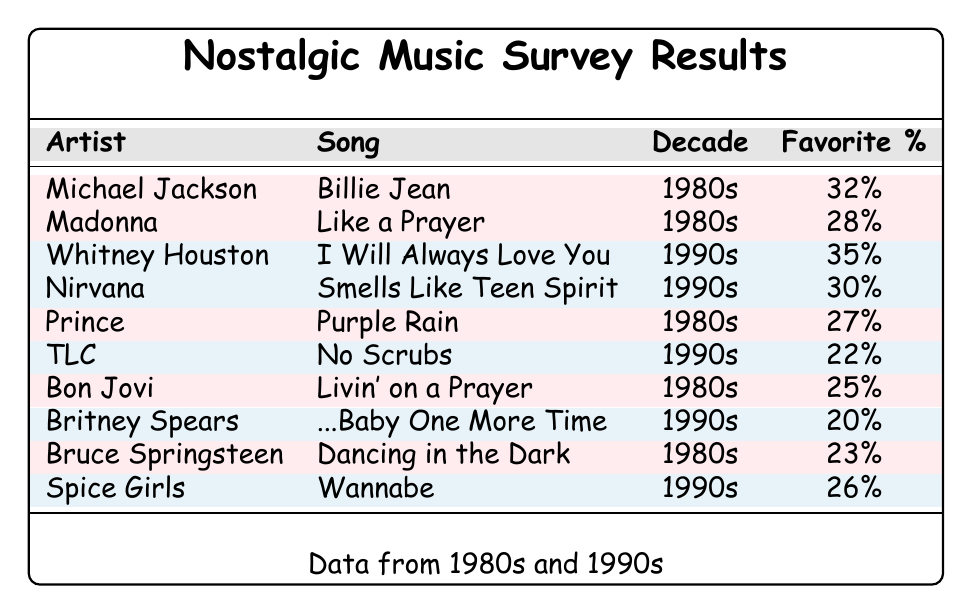What percentage of respondents favored Michael Jackson's "Billie Jean"? The table shows that the favorite percentage for Michael Jackson's song "Billie Jean" is listed as 32%.
Answer: 32% Which song had the highest favorite percentage? According to the table, Whitney Houston's song "I Will Always Love You" has the highest favorite percentage at 35%.
Answer: 35% What do the favorite percentages from the 1980s look like in comparison to the 1990s? The 1980s has three entries: Michael Jackson (32%), Madonna (28%), Prince (27%), and the average for this decade is (32 + 28 + 27 + 25 + 23) / 5 = 27%. The 1990s contains five entries: Whitney Houston (35%), Nirvana (30%), TLC (22%), Britney Spears (20%), and Spice Girls (26%), leading to an average of (35 + 30 + 22 + 20 + 26) / 5 = 26.6%. Therefore, 1980s average is higher than 1990s average.
Answer: The 1980s average (27%) is higher than the 1990s average (26.6%) How many different artists are represented in the survey results? The table lists ten artists, with each row representing a unique entry for an artist.
Answer: 10 Did any artist from the 1990s have a higher favorite percentage than the highest from the 1980s? The highest percentage from the 1980s is 32% for Michael Jackson, while the highest from the 1990s is 35% for Whitney Houston, which is indeed higher.
Answer: Yes What is the total favorite percentage of songs from both decades combined? To find the total, add all percentages from both decades: 32 + 28 + 35 + 30 + 27 + 22 + 25 + 20 + 23 + 26 =  298.
Answer: 298 Which decade had more songs listed in the survey? There are five songs from the 1980s and five songs from the 1990s, meaning they are equal in count.
Answer: Neither; they are equal What is the difference in favorite percentage between the highest and lowest ranked songs in the 1990s? The highest favorite percentage in the 1990s is 35% for Whitney Houston, and the lowest is 20% for Britney Spears. The difference is 35 - 20 = 15%.
Answer: 15% How many songs were listed for each decade? The table shows five songs listed for the 1980s and five songs for the 1990s.
Answer: 5 for each decade What percentage of respondents preferred TLC's "No Scrubs"? TLC's song "No Scrubs" has a favorite percentage of 22%, as shown in the table.
Answer: 22% Is the favorite percentage of "Purple Rain" by Prince lower than the average percentage of songs from the 1980s? "Purple Rain" has a favorite percentage of 27%, and the average for 1980s (27%) indicates they are equal.
Answer: No, they are equal 